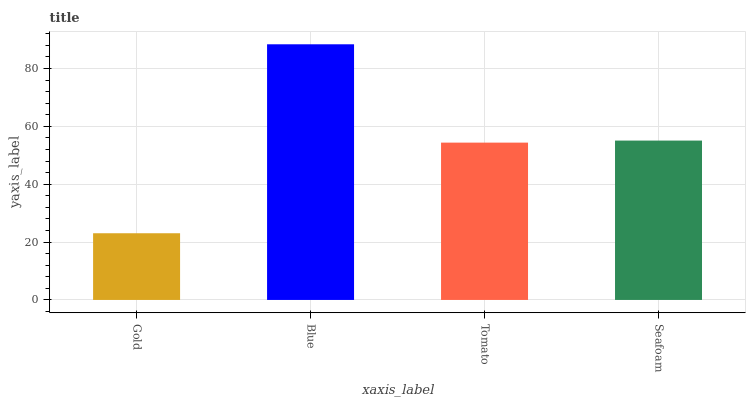Is Gold the minimum?
Answer yes or no. Yes. Is Blue the maximum?
Answer yes or no. Yes. Is Tomato the minimum?
Answer yes or no. No. Is Tomato the maximum?
Answer yes or no. No. Is Blue greater than Tomato?
Answer yes or no. Yes. Is Tomato less than Blue?
Answer yes or no. Yes. Is Tomato greater than Blue?
Answer yes or no. No. Is Blue less than Tomato?
Answer yes or no. No. Is Seafoam the high median?
Answer yes or no. Yes. Is Tomato the low median?
Answer yes or no. Yes. Is Tomato the high median?
Answer yes or no. No. Is Gold the low median?
Answer yes or no. No. 